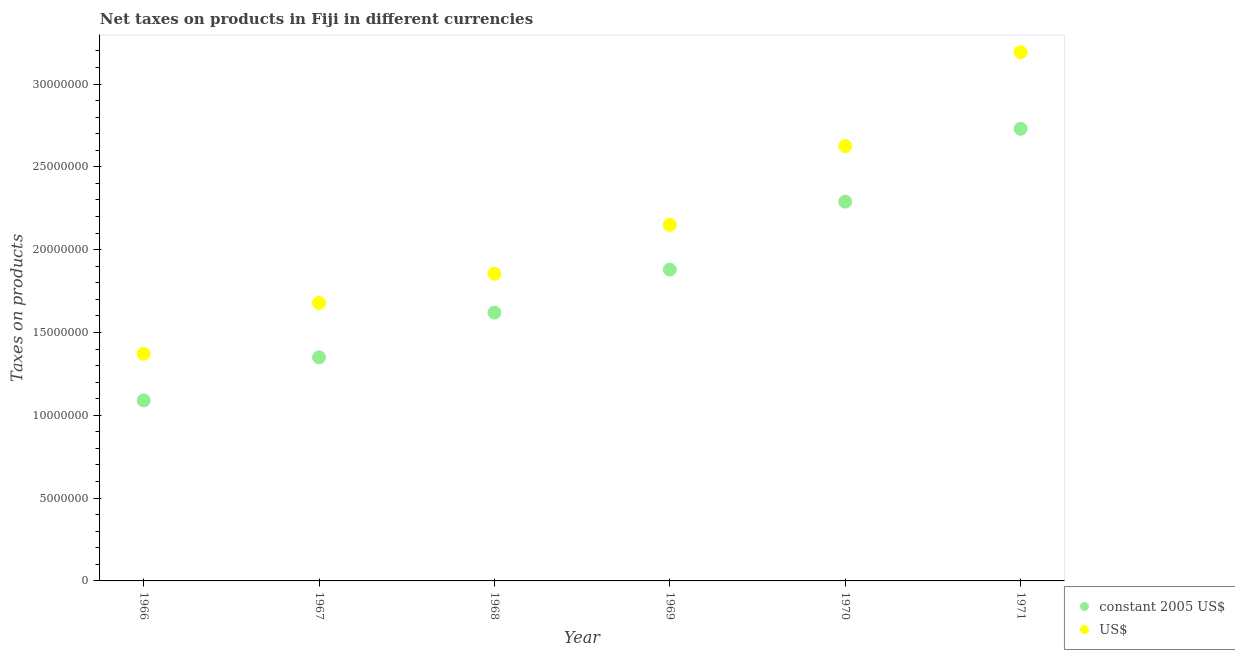How many different coloured dotlines are there?
Provide a succinct answer. 2. Is the number of dotlines equal to the number of legend labels?
Keep it short and to the point. Yes. What is the net taxes in constant 2005 us$ in 1968?
Your answer should be compact. 1.62e+07. Across all years, what is the maximum net taxes in us$?
Give a very brief answer. 3.19e+07. Across all years, what is the minimum net taxes in us$?
Your answer should be compact. 1.37e+07. In which year was the net taxes in us$ minimum?
Offer a terse response. 1966. What is the total net taxes in constant 2005 us$ in the graph?
Your response must be concise. 1.10e+08. What is the difference between the net taxes in constant 2005 us$ in 1966 and that in 1967?
Offer a very short reply. -2.60e+06. What is the difference between the net taxes in constant 2005 us$ in 1968 and the net taxes in us$ in 1970?
Your answer should be very brief. -1.01e+07. What is the average net taxes in us$ per year?
Ensure brevity in your answer.  2.15e+07. In the year 1970, what is the difference between the net taxes in constant 2005 us$ and net taxes in us$?
Give a very brief answer. -3.35e+06. In how many years, is the net taxes in constant 2005 us$ greater than 15000000 units?
Ensure brevity in your answer.  4. What is the ratio of the net taxes in us$ in 1966 to that in 1970?
Your answer should be compact. 0.52. Is the net taxes in us$ in 1966 less than that in 1969?
Give a very brief answer. Yes. Is the difference between the net taxes in constant 2005 us$ in 1968 and 1969 greater than the difference between the net taxes in us$ in 1968 and 1969?
Ensure brevity in your answer.  Yes. What is the difference between the highest and the second highest net taxes in constant 2005 us$?
Your answer should be very brief. 4.40e+06. What is the difference between the highest and the lowest net taxes in us$?
Keep it short and to the point. 1.82e+07. Is the net taxes in constant 2005 us$ strictly greater than the net taxes in us$ over the years?
Provide a succinct answer. No. How many dotlines are there?
Ensure brevity in your answer.  2. Does the graph contain any zero values?
Your answer should be compact. No. Does the graph contain grids?
Provide a short and direct response. No. How are the legend labels stacked?
Offer a very short reply. Vertical. What is the title of the graph?
Ensure brevity in your answer.  Net taxes on products in Fiji in different currencies. Does "Rural" appear as one of the legend labels in the graph?
Keep it short and to the point. No. What is the label or title of the Y-axis?
Your answer should be very brief. Taxes on products. What is the Taxes on products in constant 2005 US$ in 1966?
Give a very brief answer. 1.09e+07. What is the Taxes on products of US$ in 1966?
Your answer should be very brief. 1.37e+07. What is the Taxes on products in constant 2005 US$ in 1967?
Your answer should be compact. 1.35e+07. What is the Taxes on products in US$ in 1967?
Ensure brevity in your answer.  1.68e+07. What is the Taxes on products in constant 2005 US$ in 1968?
Make the answer very short. 1.62e+07. What is the Taxes on products in US$ in 1968?
Provide a succinct answer. 1.86e+07. What is the Taxes on products of constant 2005 US$ in 1969?
Your response must be concise. 1.88e+07. What is the Taxes on products in US$ in 1969?
Your answer should be compact. 2.15e+07. What is the Taxes on products of constant 2005 US$ in 1970?
Provide a short and direct response. 2.29e+07. What is the Taxes on products of US$ in 1970?
Make the answer very short. 2.63e+07. What is the Taxes on products of constant 2005 US$ in 1971?
Give a very brief answer. 2.73e+07. What is the Taxes on products of US$ in 1971?
Ensure brevity in your answer.  3.19e+07. Across all years, what is the maximum Taxes on products of constant 2005 US$?
Ensure brevity in your answer.  2.73e+07. Across all years, what is the maximum Taxes on products in US$?
Provide a short and direct response. 3.19e+07. Across all years, what is the minimum Taxes on products in constant 2005 US$?
Your response must be concise. 1.09e+07. Across all years, what is the minimum Taxes on products in US$?
Your answer should be compact. 1.37e+07. What is the total Taxes on products in constant 2005 US$ in the graph?
Make the answer very short. 1.10e+08. What is the total Taxes on products of US$ in the graph?
Your response must be concise. 1.29e+08. What is the difference between the Taxes on products of constant 2005 US$ in 1966 and that in 1967?
Your answer should be compact. -2.60e+06. What is the difference between the Taxes on products in US$ in 1966 and that in 1967?
Your response must be concise. -3.07e+06. What is the difference between the Taxes on products of constant 2005 US$ in 1966 and that in 1968?
Your response must be concise. -5.30e+06. What is the difference between the Taxes on products in US$ in 1966 and that in 1968?
Your answer should be very brief. -4.84e+06. What is the difference between the Taxes on products in constant 2005 US$ in 1966 and that in 1969?
Give a very brief answer. -7.90e+06. What is the difference between the Taxes on products in US$ in 1966 and that in 1969?
Your answer should be compact. -7.79e+06. What is the difference between the Taxes on products in constant 2005 US$ in 1966 and that in 1970?
Give a very brief answer. -1.20e+07. What is the difference between the Taxes on products in US$ in 1966 and that in 1970?
Provide a succinct answer. -1.25e+07. What is the difference between the Taxes on products of constant 2005 US$ in 1966 and that in 1971?
Make the answer very short. -1.64e+07. What is the difference between the Taxes on products of US$ in 1966 and that in 1971?
Keep it short and to the point. -1.82e+07. What is the difference between the Taxes on products in constant 2005 US$ in 1967 and that in 1968?
Offer a very short reply. -2.70e+06. What is the difference between the Taxes on products of US$ in 1967 and that in 1968?
Ensure brevity in your answer.  -1.77e+06. What is the difference between the Taxes on products in constant 2005 US$ in 1967 and that in 1969?
Provide a short and direct response. -5.30e+06. What is the difference between the Taxes on products of US$ in 1967 and that in 1969?
Make the answer very short. -4.72e+06. What is the difference between the Taxes on products of constant 2005 US$ in 1967 and that in 1970?
Make the answer very short. -9.40e+06. What is the difference between the Taxes on products in US$ in 1967 and that in 1970?
Your response must be concise. -9.47e+06. What is the difference between the Taxes on products of constant 2005 US$ in 1967 and that in 1971?
Provide a short and direct response. -1.38e+07. What is the difference between the Taxes on products in US$ in 1967 and that in 1971?
Make the answer very short. -1.51e+07. What is the difference between the Taxes on products of constant 2005 US$ in 1968 and that in 1969?
Give a very brief answer. -2.60e+06. What is the difference between the Taxes on products of US$ in 1968 and that in 1969?
Offer a terse response. -2.95e+06. What is the difference between the Taxes on products of constant 2005 US$ in 1968 and that in 1970?
Offer a terse response. -6.70e+06. What is the difference between the Taxes on products of US$ in 1968 and that in 1970?
Offer a very short reply. -7.70e+06. What is the difference between the Taxes on products in constant 2005 US$ in 1968 and that in 1971?
Give a very brief answer. -1.11e+07. What is the difference between the Taxes on products of US$ in 1968 and that in 1971?
Provide a succinct answer. -1.34e+07. What is the difference between the Taxes on products of constant 2005 US$ in 1969 and that in 1970?
Offer a terse response. -4.10e+06. What is the difference between the Taxes on products of US$ in 1969 and that in 1970?
Your answer should be very brief. -4.75e+06. What is the difference between the Taxes on products of constant 2005 US$ in 1969 and that in 1971?
Your answer should be very brief. -8.50e+06. What is the difference between the Taxes on products of US$ in 1969 and that in 1971?
Your answer should be compact. -1.04e+07. What is the difference between the Taxes on products of constant 2005 US$ in 1970 and that in 1971?
Keep it short and to the point. -4.40e+06. What is the difference between the Taxes on products of US$ in 1970 and that in 1971?
Make the answer very short. -5.67e+06. What is the difference between the Taxes on products in constant 2005 US$ in 1966 and the Taxes on products in US$ in 1967?
Offer a very short reply. -5.88e+06. What is the difference between the Taxes on products in constant 2005 US$ in 1966 and the Taxes on products in US$ in 1968?
Give a very brief answer. -7.65e+06. What is the difference between the Taxes on products in constant 2005 US$ in 1966 and the Taxes on products in US$ in 1969?
Your response must be concise. -1.06e+07. What is the difference between the Taxes on products in constant 2005 US$ in 1966 and the Taxes on products in US$ in 1970?
Give a very brief answer. -1.54e+07. What is the difference between the Taxes on products of constant 2005 US$ in 1966 and the Taxes on products of US$ in 1971?
Keep it short and to the point. -2.10e+07. What is the difference between the Taxes on products of constant 2005 US$ in 1967 and the Taxes on products of US$ in 1968?
Ensure brevity in your answer.  -5.05e+06. What is the difference between the Taxes on products in constant 2005 US$ in 1967 and the Taxes on products in US$ in 1969?
Provide a succinct answer. -8.00e+06. What is the difference between the Taxes on products of constant 2005 US$ in 1967 and the Taxes on products of US$ in 1970?
Make the answer very short. -1.28e+07. What is the difference between the Taxes on products of constant 2005 US$ in 1967 and the Taxes on products of US$ in 1971?
Keep it short and to the point. -1.84e+07. What is the difference between the Taxes on products of constant 2005 US$ in 1968 and the Taxes on products of US$ in 1969?
Give a very brief answer. -5.30e+06. What is the difference between the Taxes on products in constant 2005 US$ in 1968 and the Taxes on products in US$ in 1970?
Your answer should be compact. -1.01e+07. What is the difference between the Taxes on products of constant 2005 US$ in 1968 and the Taxes on products of US$ in 1971?
Your response must be concise. -1.57e+07. What is the difference between the Taxes on products in constant 2005 US$ in 1969 and the Taxes on products in US$ in 1970?
Provide a short and direct response. -7.45e+06. What is the difference between the Taxes on products in constant 2005 US$ in 1969 and the Taxes on products in US$ in 1971?
Make the answer very short. -1.31e+07. What is the difference between the Taxes on products of constant 2005 US$ in 1970 and the Taxes on products of US$ in 1971?
Ensure brevity in your answer.  -9.02e+06. What is the average Taxes on products of constant 2005 US$ per year?
Provide a short and direct response. 1.83e+07. What is the average Taxes on products in US$ per year?
Your answer should be very brief. 2.15e+07. In the year 1966, what is the difference between the Taxes on products in constant 2005 US$ and Taxes on products in US$?
Give a very brief answer. -2.81e+06. In the year 1967, what is the difference between the Taxes on products of constant 2005 US$ and Taxes on products of US$?
Offer a terse response. -3.28e+06. In the year 1968, what is the difference between the Taxes on products of constant 2005 US$ and Taxes on products of US$?
Give a very brief answer. -2.35e+06. In the year 1969, what is the difference between the Taxes on products in constant 2005 US$ and Taxes on products in US$?
Offer a terse response. -2.70e+06. In the year 1970, what is the difference between the Taxes on products in constant 2005 US$ and Taxes on products in US$?
Keep it short and to the point. -3.35e+06. In the year 1971, what is the difference between the Taxes on products in constant 2005 US$ and Taxes on products in US$?
Make the answer very short. -4.62e+06. What is the ratio of the Taxes on products in constant 2005 US$ in 1966 to that in 1967?
Offer a terse response. 0.81. What is the ratio of the Taxes on products of US$ in 1966 to that in 1967?
Offer a terse response. 0.82. What is the ratio of the Taxes on products of constant 2005 US$ in 1966 to that in 1968?
Your response must be concise. 0.67. What is the ratio of the Taxes on products of US$ in 1966 to that in 1968?
Provide a short and direct response. 0.74. What is the ratio of the Taxes on products in constant 2005 US$ in 1966 to that in 1969?
Your answer should be very brief. 0.58. What is the ratio of the Taxes on products of US$ in 1966 to that in 1969?
Provide a short and direct response. 0.64. What is the ratio of the Taxes on products of constant 2005 US$ in 1966 to that in 1970?
Your answer should be compact. 0.48. What is the ratio of the Taxes on products of US$ in 1966 to that in 1970?
Ensure brevity in your answer.  0.52. What is the ratio of the Taxes on products in constant 2005 US$ in 1966 to that in 1971?
Offer a very short reply. 0.4. What is the ratio of the Taxes on products of US$ in 1966 to that in 1971?
Offer a terse response. 0.43. What is the ratio of the Taxes on products of constant 2005 US$ in 1967 to that in 1968?
Your answer should be very brief. 0.83. What is the ratio of the Taxes on products in US$ in 1967 to that in 1968?
Your answer should be compact. 0.9. What is the ratio of the Taxes on products in constant 2005 US$ in 1967 to that in 1969?
Give a very brief answer. 0.72. What is the ratio of the Taxes on products of US$ in 1967 to that in 1969?
Give a very brief answer. 0.78. What is the ratio of the Taxes on products in constant 2005 US$ in 1967 to that in 1970?
Your answer should be very brief. 0.59. What is the ratio of the Taxes on products in US$ in 1967 to that in 1970?
Offer a very short reply. 0.64. What is the ratio of the Taxes on products in constant 2005 US$ in 1967 to that in 1971?
Make the answer very short. 0.49. What is the ratio of the Taxes on products of US$ in 1967 to that in 1971?
Your response must be concise. 0.53. What is the ratio of the Taxes on products of constant 2005 US$ in 1968 to that in 1969?
Your response must be concise. 0.86. What is the ratio of the Taxes on products of US$ in 1968 to that in 1969?
Keep it short and to the point. 0.86. What is the ratio of the Taxes on products in constant 2005 US$ in 1968 to that in 1970?
Offer a very short reply. 0.71. What is the ratio of the Taxes on products in US$ in 1968 to that in 1970?
Offer a terse response. 0.71. What is the ratio of the Taxes on products in constant 2005 US$ in 1968 to that in 1971?
Provide a short and direct response. 0.59. What is the ratio of the Taxes on products of US$ in 1968 to that in 1971?
Your response must be concise. 0.58. What is the ratio of the Taxes on products of constant 2005 US$ in 1969 to that in 1970?
Offer a very short reply. 0.82. What is the ratio of the Taxes on products of US$ in 1969 to that in 1970?
Give a very brief answer. 0.82. What is the ratio of the Taxes on products of constant 2005 US$ in 1969 to that in 1971?
Ensure brevity in your answer.  0.69. What is the ratio of the Taxes on products of US$ in 1969 to that in 1971?
Offer a very short reply. 0.67. What is the ratio of the Taxes on products in constant 2005 US$ in 1970 to that in 1971?
Make the answer very short. 0.84. What is the ratio of the Taxes on products in US$ in 1970 to that in 1971?
Provide a succinct answer. 0.82. What is the difference between the highest and the second highest Taxes on products of constant 2005 US$?
Ensure brevity in your answer.  4.40e+06. What is the difference between the highest and the second highest Taxes on products of US$?
Give a very brief answer. 5.67e+06. What is the difference between the highest and the lowest Taxes on products of constant 2005 US$?
Give a very brief answer. 1.64e+07. What is the difference between the highest and the lowest Taxes on products in US$?
Keep it short and to the point. 1.82e+07. 